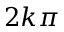<formula> <loc_0><loc_0><loc_500><loc_500>2 k { \pi }</formula> 